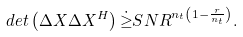<formula> <loc_0><loc_0><loc_500><loc_500>d e t \left ( \Delta X \Delta X ^ { H } \right ) \dot { \geq } S N R ^ { n _ { t } \left ( 1 - \frac { r } { n _ { t } } \right ) } .</formula> 